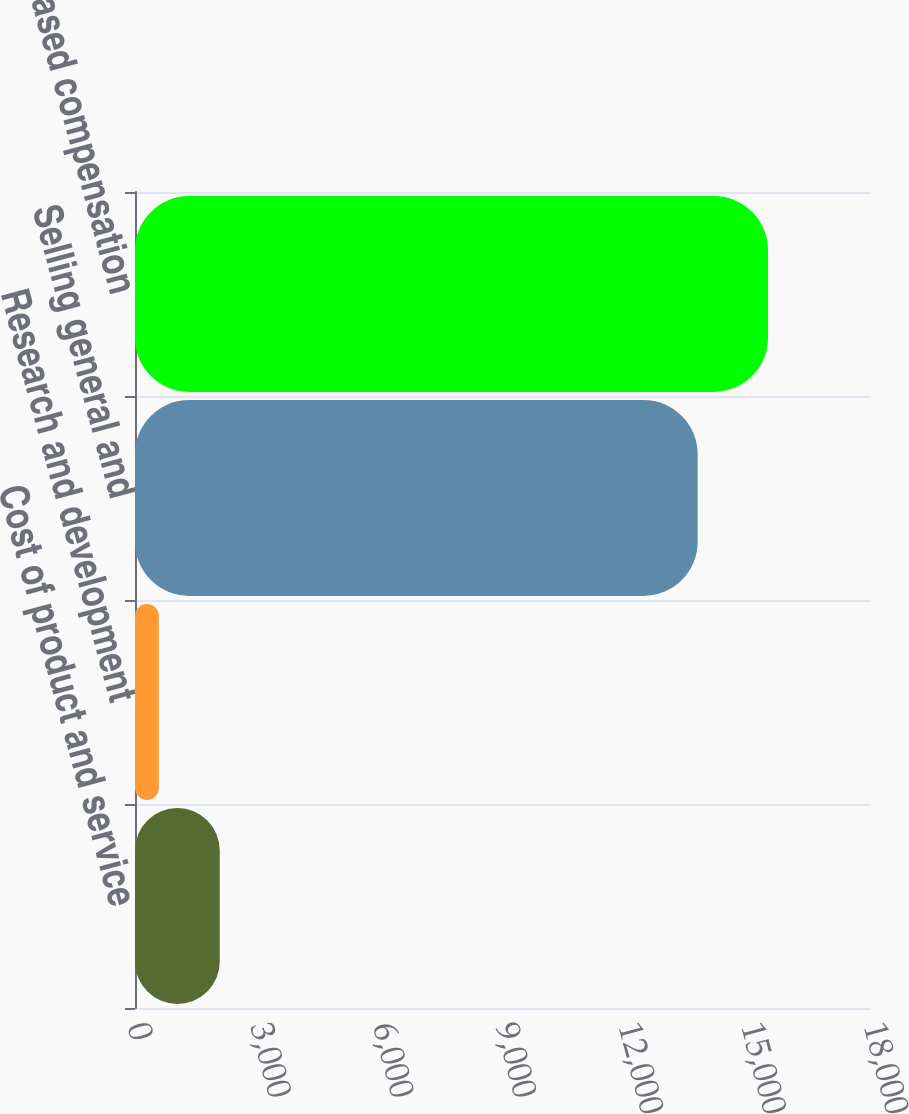Convert chart. <chart><loc_0><loc_0><loc_500><loc_500><bar_chart><fcel>Cost of product and service<fcel>Research and development<fcel>Selling general and<fcel>Total stock-based compensation<nl><fcel>2072.9<fcel>583<fcel>13760<fcel>15482<nl></chart> 